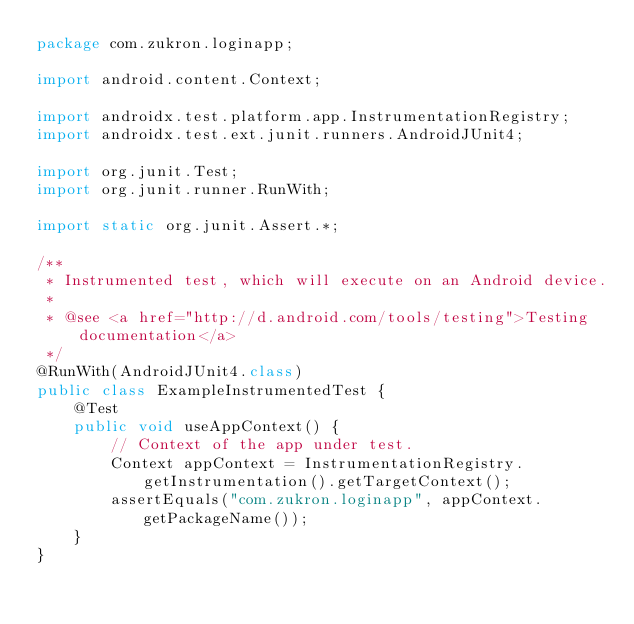<code> <loc_0><loc_0><loc_500><loc_500><_Java_>package com.zukron.loginapp;

import android.content.Context;

import androidx.test.platform.app.InstrumentationRegistry;
import androidx.test.ext.junit.runners.AndroidJUnit4;

import org.junit.Test;
import org.junit.runner.RunWith;

import static org.junit.Assert.*;

/**
 * Instrumented test, which will execute on an Android device.
 *
 * @see <a href="http://d.android.com/tools/testing">Testing documentation</a>
 */
@RunWith(AndroidJUnit4.class)
public class ExampleInstrumentedTest {
    @Test
    public void useAppContext() {
        // Context of the app under test.
        Context appContext = InstrumentationRegistry.getInstrumentation().getTargetContext();
        assertEquals("com.zukron.loginapp", appContext.getPackageName());
    }
}</code> 